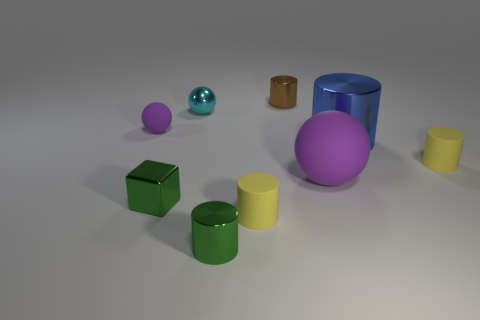How many yellow cylinders must be subtracted to get 1 yellow cylinders? 1 Add 1 tiny blue metal things. How many objects exist? 10 Subtract all tiny cylinders. How many cylinders are left? 1 Subtract 2 cylinders. How many cylinders are left? 3 Subtract all red cylinders. Subtract all blue blocks. How many cylinders are left? 5 Subtract all green cubes. How many gray cylinders are left? 0 Subtract all green cylinders. Subtract all big brown matte spheres. How many objects are left? 8 Add 2 tiny green objects. How many tiny green objects are left? 4 Add 7 large red metallic balls. How many large red metallic balls exist? 7 Subtract all blue cylinders. How many cylinders are left? 4 